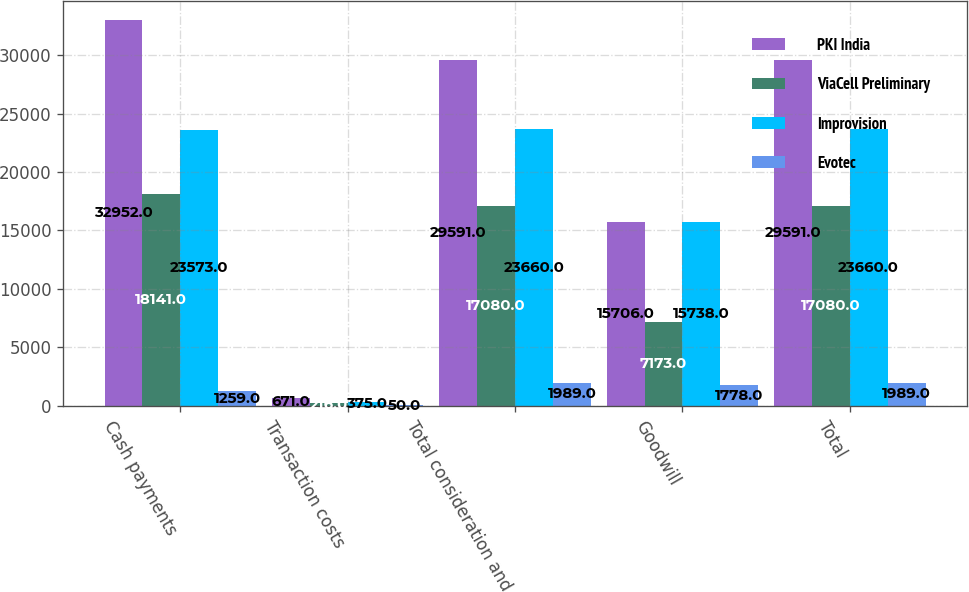<chart> <loc_0><loc_0><loc_500><loc_500><stacked_bar_chart><ecel><fcel>Cash payments<fcel>Transaction costs<fcel>Total consideration and<fcel>Goodwill<fcel>Total<nl><fcel>PKI India<fcel>32952<fcel>671<fcel>29591<fcel>15706<fcel>29591<nl><fcel>ViaCell Preliminary<fcel>18141<fcel>216<fcel>17080<fcel>7173<fcel>17080<nl><fcel>Improvision<fcel>23573<fcel>375<fcel>23660<fcel>15738<fcel>23660<nl><fcel>Evotec<fcel>1259<fcel>50<fcel>1989<fcel>1778<fcel>1989<nl></chart> 